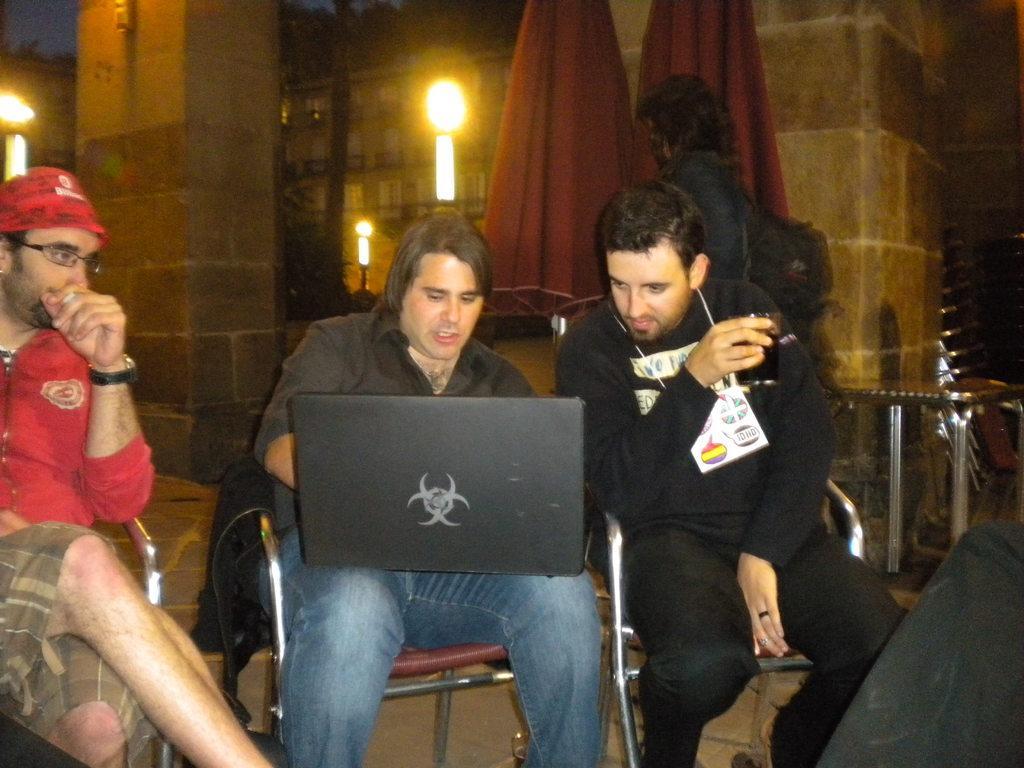Could you give a brief overview of what you see in this image? In this image there are three men sitting on the chair, there is a laptop, there is a glass, there is a woman standing, she is wearing a bag, there are two umbrellas towards the top of the image, there is a table towards the right of the image, there are objects towards the right of the image, there is a pillar towards the left of the image, there is the wall, there are lights, there are buildings, there are trees towards the top of the image, there is the sky towards the top of the image. 